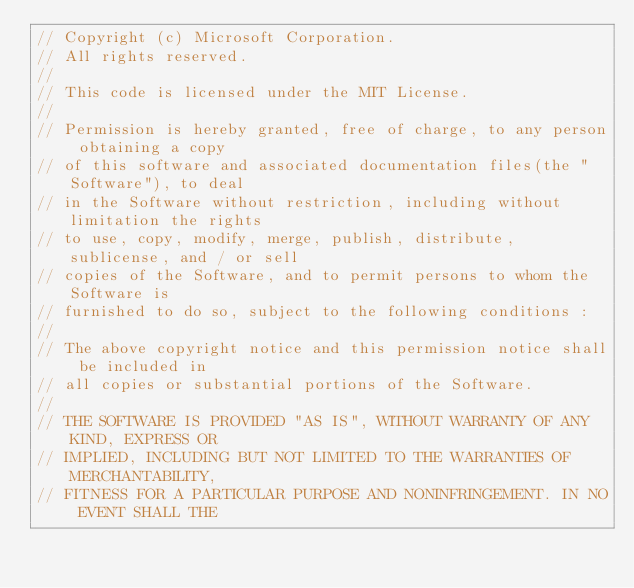<code> <loc_0><loc_0><loc_500><loc_500><_C_>// Copyright (c) Microsoft Corporation.
// All rights reserved.
//
// This code is licensed under the MIT License.
//
// Permission is hereby granted, free of charge, to any person obtaining a copy
// of this software and associated documentation files(the "Software"), to deal
// in the Software without restriction, including without limitation the rights
// to use, copy, modify, merge, publish, distribute, sublicense, and / or sell
// copies of the Software, and to permit persons to whom the Software is
// furnished to do so, subject to the following conditions :
//
// The above copyright notice and this permission notice shall be included in
// all copies or substantial portions of the Software.
//
// THE SOFTWARE IS PROVIDED "AS IS", WITHOUT WARRANTY OF ANY KIND, EXPRESS OR
// IMPLIED, INCLUDING BUT NOT LIMITED TO THE WARRANTIES OF MERCHANTABILITY,
// FITNESS FOR A PARTICULAR PURPOSE AND NONINFRINGEMENT. IN NO EVENT SHALL THE</code> 